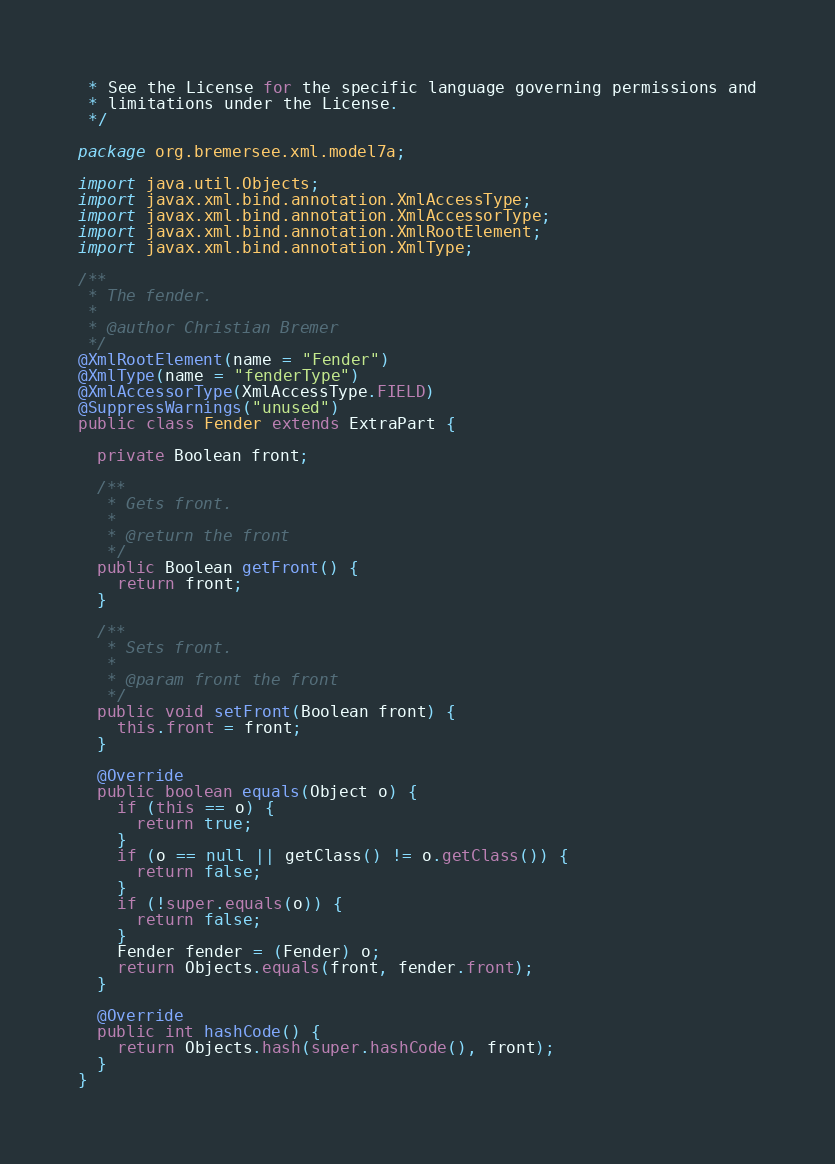Convert code to text. <code><loc_0><loc_0><loc_500><loc_500><_Java_> * See the License for the specific language governing permissions and
 * limitations under the License.
 */

package org.bremersee.xml.model7a;

import java.util.Objects;
import javax.xml.bind.annotation.XmlAccessType;
import javax.xml.bind.annotation.XmlAccessorType;
import javax.xml.bind.annotation.XmlRootElement;
import javax.xml.bind.annotation.XmlType;

/**
 * The fender.
 *
 * @author Christian Bremer
 */
@XmlRootElement(name = "Fender")
@XmlType(name = "fenderType")
@XmlAccessorType(XmlAccessType.FIELD)
@SuppressWarnings("unused")
public class Fender extends ExtraPart {

  private Boolean front;

  /**
   * Gets front.
   *
   * @return the front
   */
  public Boolean getFront() {
    return front;
  }

  /**
   * Sets front.
   *
   * @param front the front
   */
  public void setFront(Boolean front) {
    this.front = front;
  }

  @Override
  public boolean equals(Object o) {
    if (this == o) {
      return true;
    }
    if (o == null || getClass() != o.getClass()) {
      return false;
    }
    if (!super.equals(o)) {
      return false;
    }
    Fender fender = (Fender) o;
    return Objects.equals(front, fender.front);
  }

  @Override
  public int hashCode() {
    return Objects.hash(super.hashCode(), front);
  }
}
</code> 